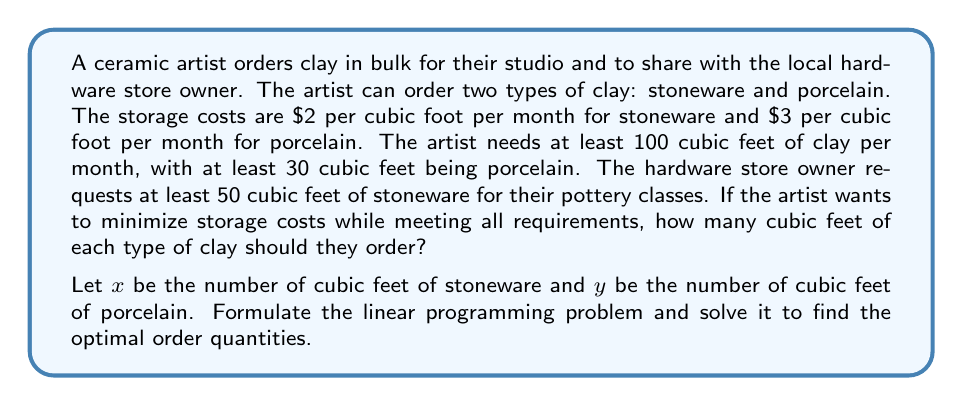Provide a solution to this math problem. To solve this linear programming problem, we need to follow these steps:

1. Define the objective function:
   We want to minimize the total storage cost, which is given by:
   $$2x + 3y$$

2. Define the constraints:
   a) Total clay requirement: $x + y \geq 100$
   b) Minimum porcelain requirement: $y \geq 30$
   c) Minimum stoneware for hardware store: $x \geq 50$
   d) Non-negativity constraints: $x \geq 0, y \geq 0$

3. Set up the linear programming problem:
   Minimize: $2x + 3y$
   Subject to:
   $$\begin{align}
   x + y &\geq 100 \\
   y &\geq 30 \\
   x &\geq 50 \\
   x, y &\geq 0
   \end{align}$$

4. Solve the problem using the corner point method:
   The feasible region is bounded by the lines:
   $x + y = 100$, $y = 30$, and $x = 50$

   The corner points are:
   (50, 50), (50, 30), and (70, 30)

5. Evaluate the objective function at each corner point:
   (50, 50): $2(50) + 3(50) = 250$
   (50, 30): $2(50) + 3(30) = 190$
   (70, 30): $2(70) + 3(30) = 230$

6. The minimum value occurs at the point (50, 30), which represents the optimal solution.

Therefore, the artist should order 50 cubic feet of stoneware and 30 cubic feet of porcelain to minimize storage costs while meeting all requirements.
Answer: The optimal order quantities are 50 cubic feet of stoneware and 30 cubic feet of porcelain. 